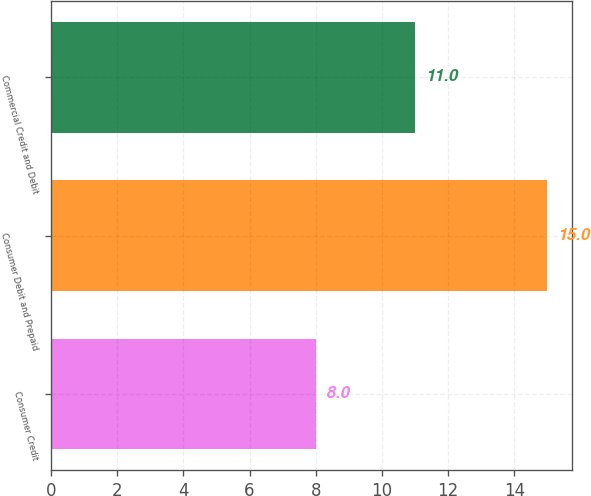Convert chart to OTSL. <chart><loc_0><loc_0><loc_500><loc_500><bar_chart><fcel>Consumer Credit<fcel>Consumer Debit and Prepaid<fcel>Commercial Credit and Debit<nl><fcel>8<fcel>15<fcel>11<nl></chart> 